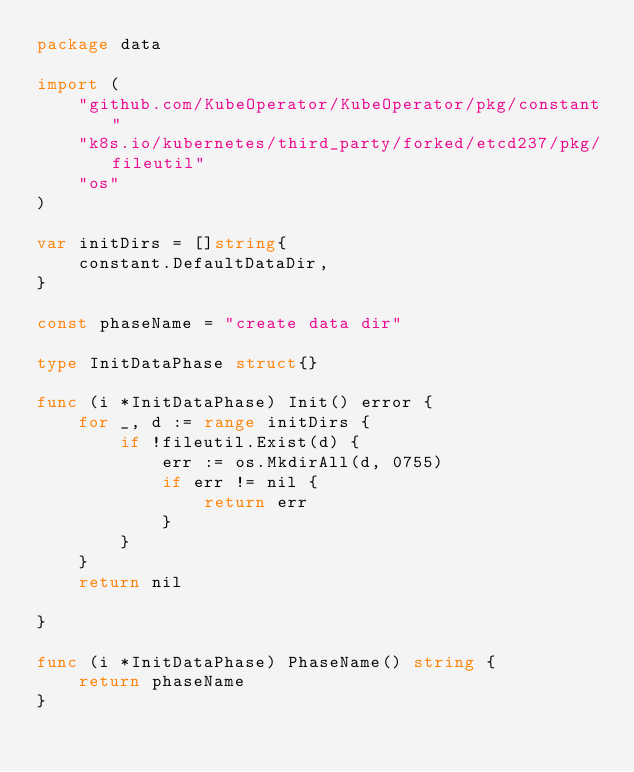<code> <loc_0><loc_0><loc_500><loc_500><_Go_>package data

import (
	"github.com/KubeOperator/KubeOperator/pkg/constant"
	"k8s.io/kubernetes/third_party/forked/etcd237/pkg/fileutil"
	"os"
)

var initDirs = []string{
	constant.DefaultDataDir,
}

const phaseName = "create data dir"

type InitDataPhase struct{}

func (i *InitDataPhase) Init() error {
	for _, d := range initDirs {
		if !fileutil.Exist(d) {
			err := os.MkdirAll(d, 0755)
			if err != nil {
				return err
			}
		}
	}
	return nil

}

func (i *InitDataPhase) PhaseName() string {
	return phaseName
}
</code> 